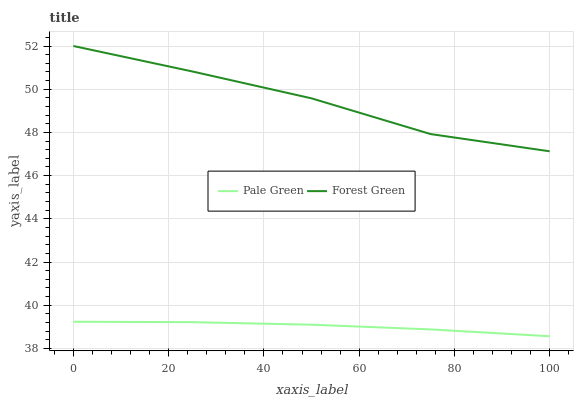Does Pale Green have the maximum area under the curve?
Answer yes or no. No. Is Pale Green the roughest?
Answer yes or no. No. Does Pale Green have the highest value?
Answer yes or no. No. Is Pale Green less than Forest Green?
Answer yes or no. Yes. Is Forest Green greater than Pale Green?
Answer yes or no. Yes. Does Pale Green intersect Forest Green?
Answer yes or no. No. 